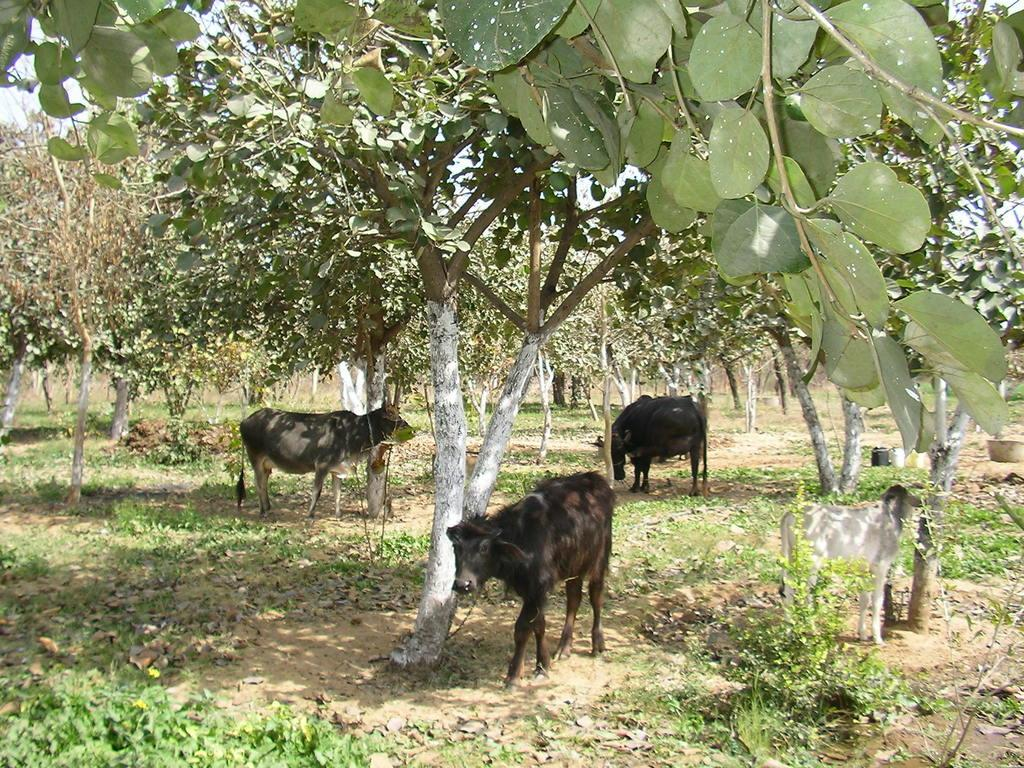What types of living organisms are present in the image? There are animals in the image. What color scheme is used for the animals? The animals are in black and white color. What can be seen in the background of the image? There are trees in the background of the image. What color are the trees? The trees are in green color. What color is the sky in the image? The sky is in white color. What type of street can be seen in the image? There is no street present in the image; it features animals, trees, and a white sky. What activity are the animals engaged in with the cork in the image? There is no cork or activity involving a cork present in the image. 